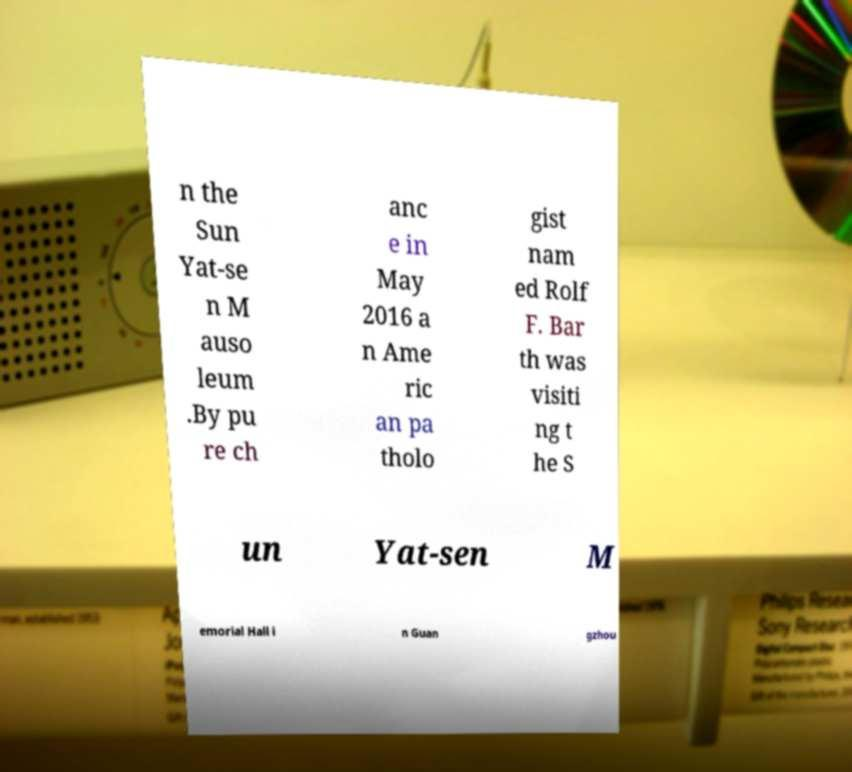Could you assist in decoding the text presented in this image and type it out clearly? n the Sun Yat-se n M auso leum .By pu re ch anc e in May 2016 a n Ame ric an pa tholo gist nam ed Rolf F. Bar th was visiti ng t he S un Yat-sen M emorial Hall i n Guan gzhou 